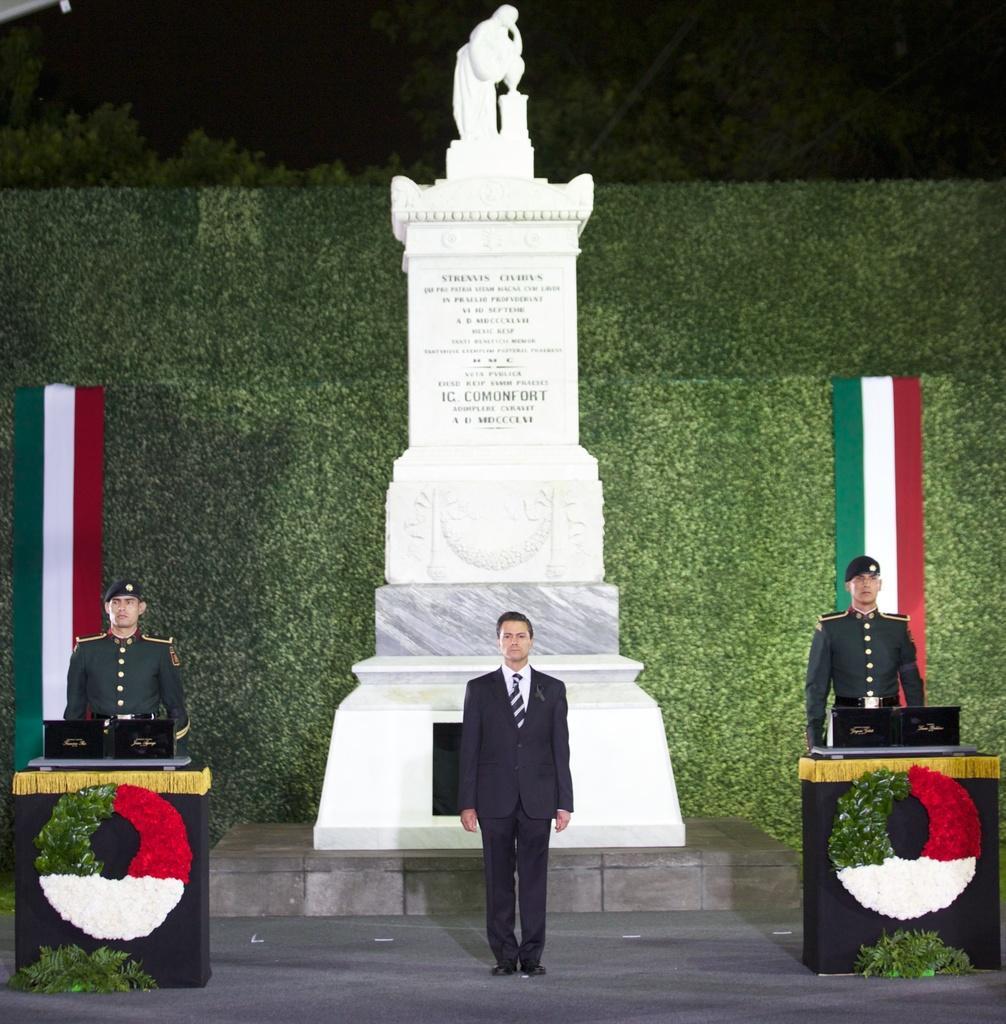Please provide a concise description of this image. In this image there are persons standing and in the background are flags and there are leaves and there is a statue and there is some text written on the wall which is white in colour and there are trees in the background. In the front there are stands and there are flower rings and on the top of the stand there are objects which are black in colour. 